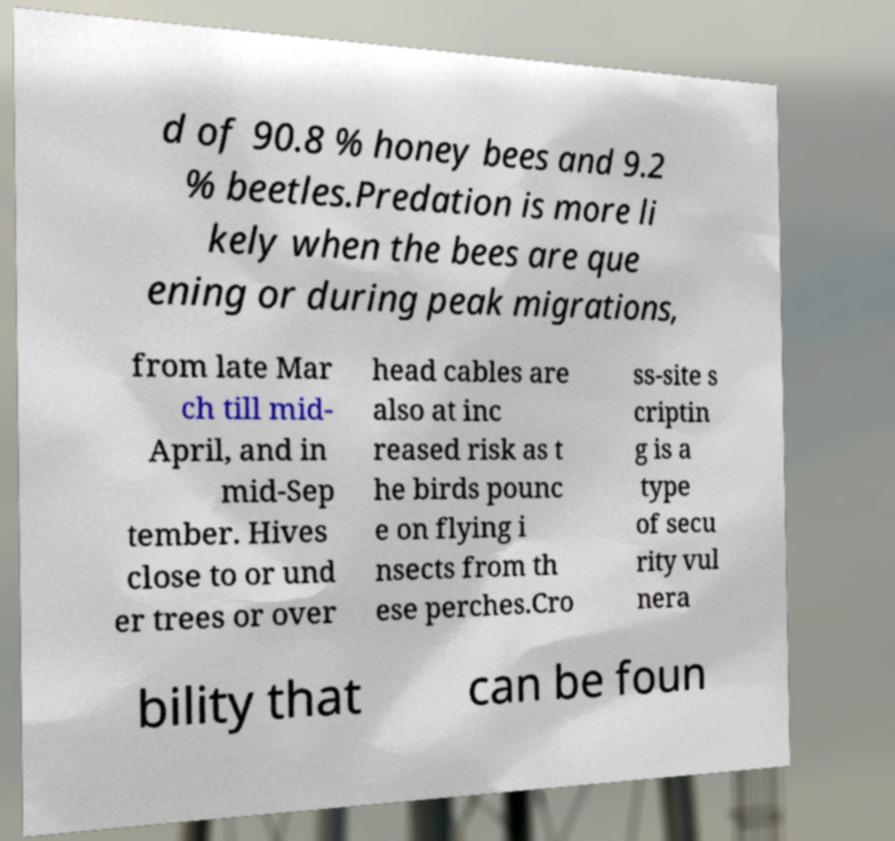Could you extract and type out the text from this image? d of 90.8 % honey bees and 9.2 % beetles.Predation is more li kely when the bees are que ening or during peak migrations, from late Mar ch till mid- April, and in mid-Sep tember. Hives close to or und er trees or over head cables are also at inc reased risk as t he birds pounc e on flying i nsects from th ese perches.Cro ss-site s criptin g is a type of secu rity vul nera bility that can be foun 